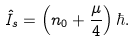Convert formula to latex. <formula><loc_0><loc_0><loc_500><loc_500>\hat { I } _ { s } = \left ( n _ { 0 } + \frac { \mu } { 4 } \right ) \hbar { . }</formula> 